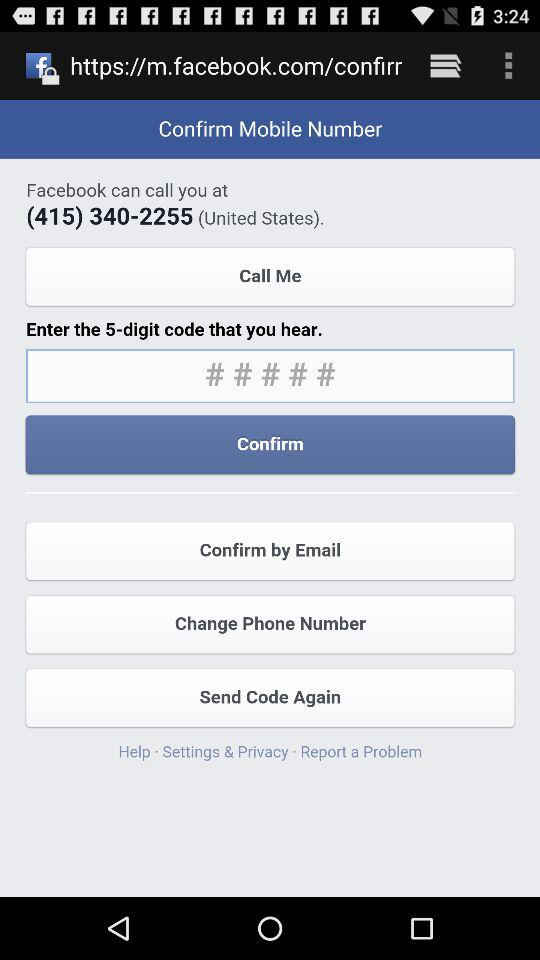How many numbers are in the text input?
Answer the question using a single word or phrase. 5 